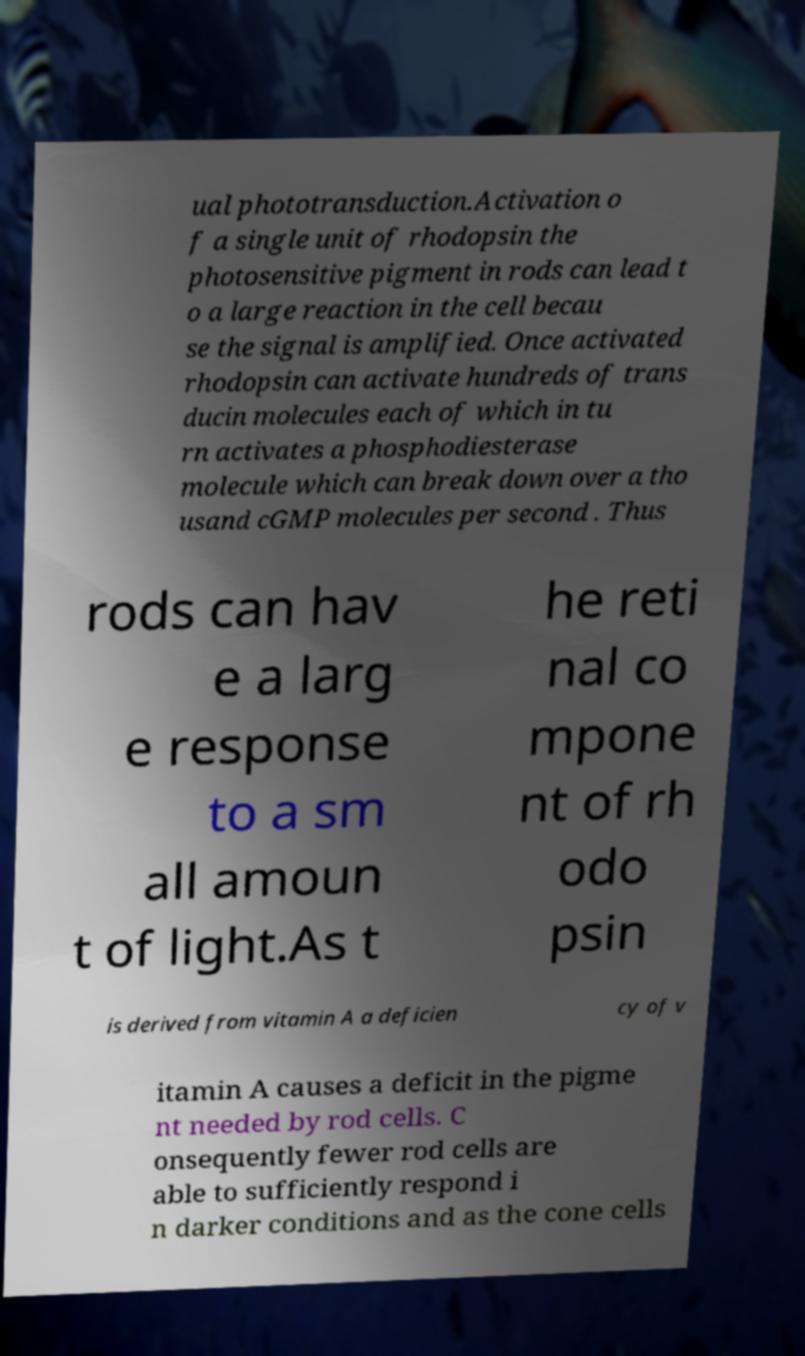For documentation purposes, I need the text within this image transcribed. Could you provide that? ual phototransduction.Activation o f a single unit of rhodopsin the photosensitive pigment in rods can lead t o a large reaction in the cell becau se the signal is amplified. Once activated rhodopsin can activate hundreds of trans ducin molecules each of which in tu rn activates a phosphodiesterase molecule which can break down over a tho usand cGMP molecules per second . Thus rods can hav e a larg e response to a sm all amoun t of light.As t he reti nal co mpone nt of rh odo psin is derived from vitamin A a deficien cy of v itamin A causes a deficit in the pigme nt needed by rod cells. C onsequently fewer rod cells are able to sufficiently respond i n darker conditions and as the cone cells 